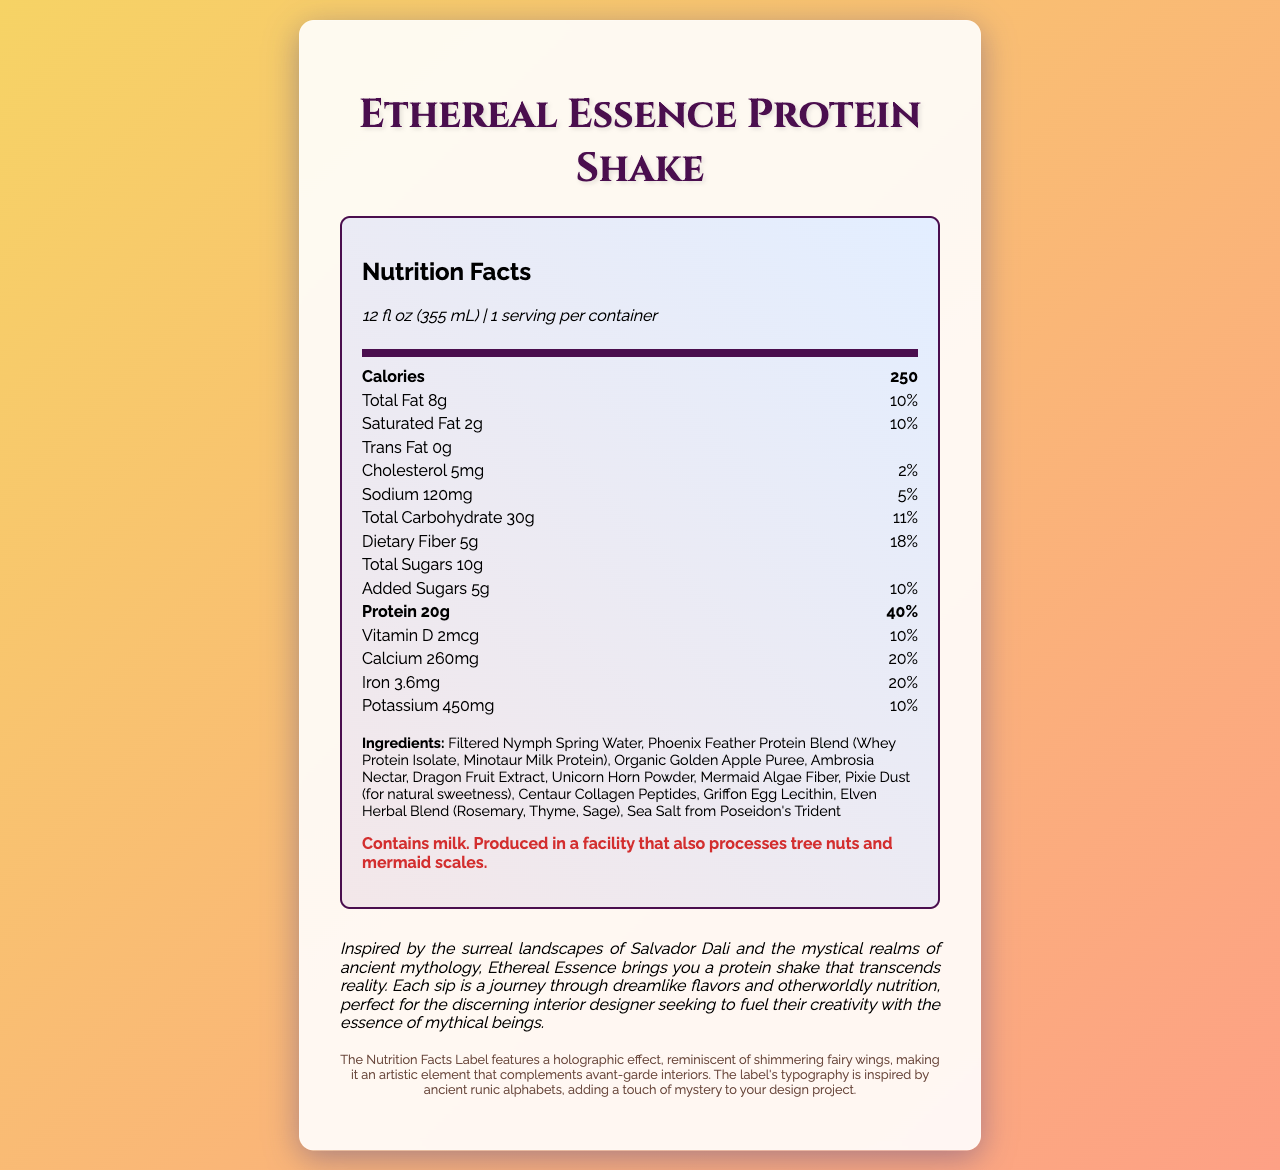what is the serving size of the Ethereal Essence Protein Shake? The serving size is listed under the Nutrition Facts header as "12 fl oz (355 mL)".
Answer: 12 fl oz (355 mL) How many calories are in one serving? Under the "Calories" section, it clearly shows 250 calories per serving.
Answer: 250 What is the amount of total fat per serving? The "Total Fat" row shows that it is 8 grams per serving.
Answer: 8g What is the daily value percentage of protein in one serving? The "Protein" row indicates that the Daily Value percentage is 40%.
Answer: 40% Which mythical ingredient blends are included in the protein shake? The ingredients list identifies the mythical ingredient blends, which are Phoenix Feather Protein Blend, Mermaid Algae Fiber, and Centaur Collagen Peptides.
Answer: Phoenix Feather Protein Blend, Mermaid Algae Fiber, Centaur Collagen Peptides What vitamins and minerals are present and their daily values? The vitamins and minerals section lists Vitamin D (10%), Calcium (20%), Iron (20%), and Potassium (10%).
Answer: Vitamin D (10%), Calcium (20%), Iron (20%), Potassium (10%) Which ingredient is responsible for the sweetness in the shake? A. Ambrosia Nectar B. Pixie Dust C. Golden Apple Puree D. Phoenix Feather Protein Blend From the ingredients list, Pixie Dust is noted as providing natural sweetness.
Answer: B. Pixie Dust What is the amount of dietary fiber in the Ethereal Essence Protein Shake? The "Dietary Fiber" row specifies that there are 5 grams of dietary fiber.
Answer: 5g How many grams of added sugars are in the shake? The "Added Sugars" row specifies that there are 5 grams of added sugars.
Answer: 5g Is there any allergen warning provided in the document? There is an allergen warning that states: 'Contains milk. Produced in a facility that also processes tree nuts and mermaid scales.'
Answer: Yes Describe the design inspiration behind the Nutrition Facts Label. The label's design, as described in the Design Inspiration Note, includes a holographic effect and runic-style typography to enhance artistic appeal.
Answer: The Nutrition Facts Label of the Ethereal Essence Protein Shake features a holographic effect reminiscent of shimmering fairy wings and typography inspired by ancient runic alphabets, intended to complement avant-garde interiors. What is the purpose of the Phoenix Feather Protein Blend in the shake? The document lists Phoenix Feather Protein Blend as an ingredient, but it does not specify its purpose.
Answer: Not enough information 